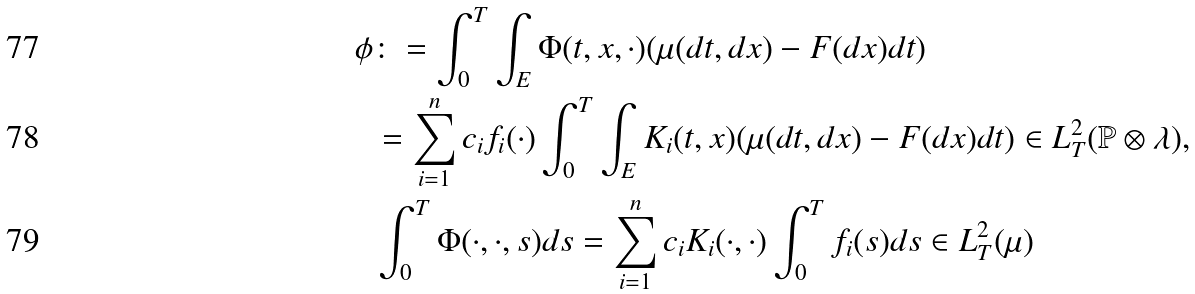<formula> <loc_0><loc_0><loc_500><loc_500>\phi & \colon = \int _ { 0 } ^ { T } \int _ { E } \Phi ( t , x , \cdot ) ( \mu ( d t , d x ) - F ( d x ) d t ) \\ & = \sum _ { i = 1 } ^ { n } c _ { i } f _ { i } ( \cdot ) \int _ { 0 } ^ { T } \int _ { E } K _ { i } ( t , x ) ( \mu ( d t , d x ) - F ( d x ) d t ) \in L _ { T } ^ { 2 } ( \mathbb { P } \otimes \lambda ) , \\ & \int _ { 0 } ^ { T } \Phi ( \cdot , \cdot , s ) d s = \sum _ { i = 1 } ^ { n } c _ { i } K _ { i } ( \cdot , \cdot ) \int _ { 0 } ^ { T } f _ { i } ( s ) d s \in L _ { T } ^ { 2 } ( \mu )</formula> 